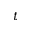<formula> <loc_0><loc_0><loc_500><loc_500>t</formula> 